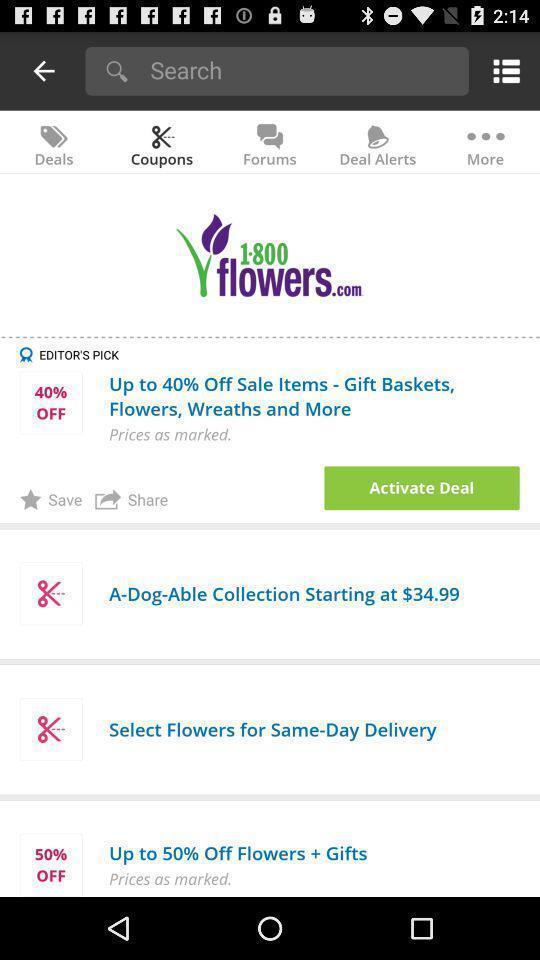Provide a textual representation of this image. Screen shows to activate deal. 